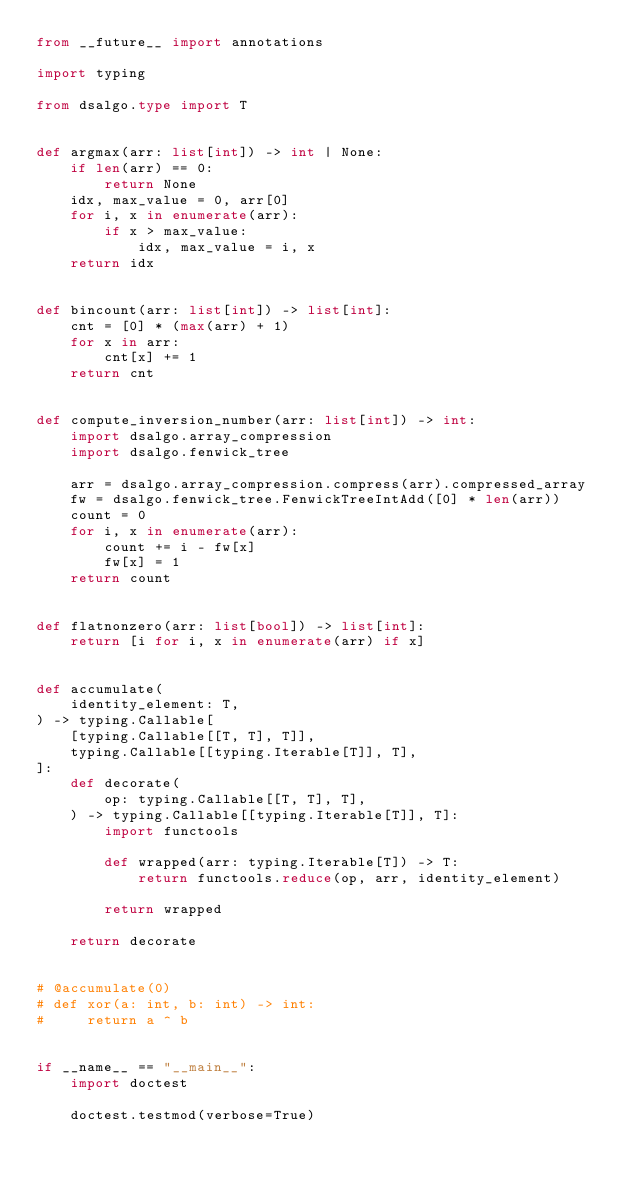Convert code to text. <code><loc_0><loc_0><loc_500><loc_500><_Python_>from __future__ import annotations

import typing

from dsalgo.type import T


def argmax(arr: list[int]) -> int | None:
    if len(arr) == 0:
        return None
    idx, max_value = 0, arr[0]
    for i, x in enumerate(arr):
        if x > max_value:
            idx, max_value = i, x
    return idx


def bincount(arr: list[int]) -> list[int]:
    cnt = [0] * (max(arr) + 1)
    for x in arr:
        cnt[x] += 1
    return cnt


def compute_inversion_number(arr: list[int]) -> int:
    import dsalgo.array_compression
    import dsalgo.fenwick_tree

    arr = dsalgo.array_compression.compress(arr).compressed_array
    fw = dsalgo.fenwick_tree.FenwickTreeIntAdd([0] * len(arr))
    count = 0
    for i, x in enumerate(arr):
        count += i - fw[x]
        fw[x] = 1
    return count


def flatnonzero(arr: list[bool]) -> list[int]:
    return [i for i, x in enumerate(arr) if x]


def accumulate(
    identity_element: T,
) -> typing.Callable[
    [typing.Callable[[T, T], T]],
    typing.Callable[[typing.Iterable[T]], T],
]:
    def decorate(
        op: typing.Callable[[T, T], T],
    ) -> typing.Callable[[typing.Iterable[T]], T]:
        import functools

        def wrapped(arr: typing.Iterable[T]) -> T:
            return functools.reduce(op, arr, identity_element)

        return wrapped

    return decorate


# @accumulate(0)
# def xor(a: int, b: int) -> int:
#     return a ^ b


if __name__ == "__main__":
    import doctest

    doctest.testmod(verbose=True)
</code> 